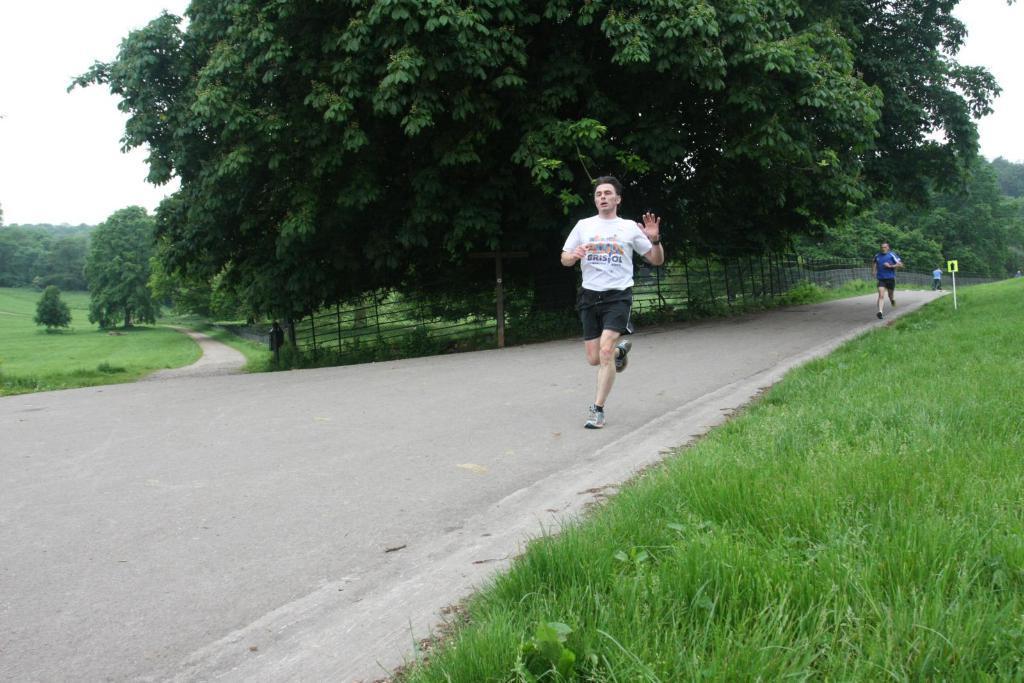In one or two sentences, can you explain what this image depicts? In this picture we can see few people, who are running on the road, beside to them we can find a sign board, grass, fence and trees. 